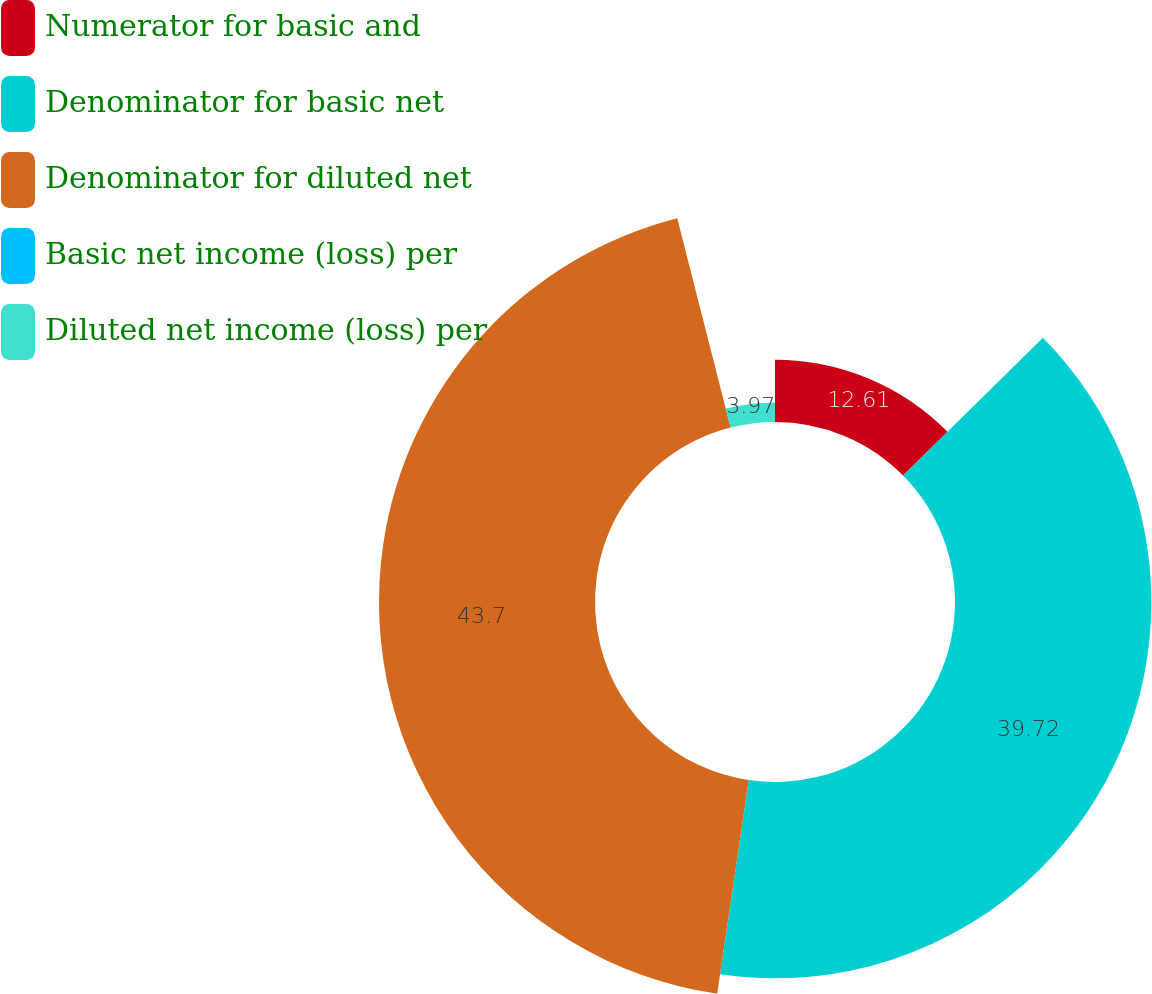Convert chart to OTSL. <chart><loc_0><loc_0><loc_500><loc_500><pie_chart><fcel>Numerator for basic and<fcel>Denominator for basic net<fcel>Denominator for diluted net<fcel>Basic net income (loss) per<fcel>Diluted net income (loss) per<nl><fcel>12.61%<fcel>39.72%<fcel>43.7%<fcel>0.0%<fcel>3.97%<nl></chart> 